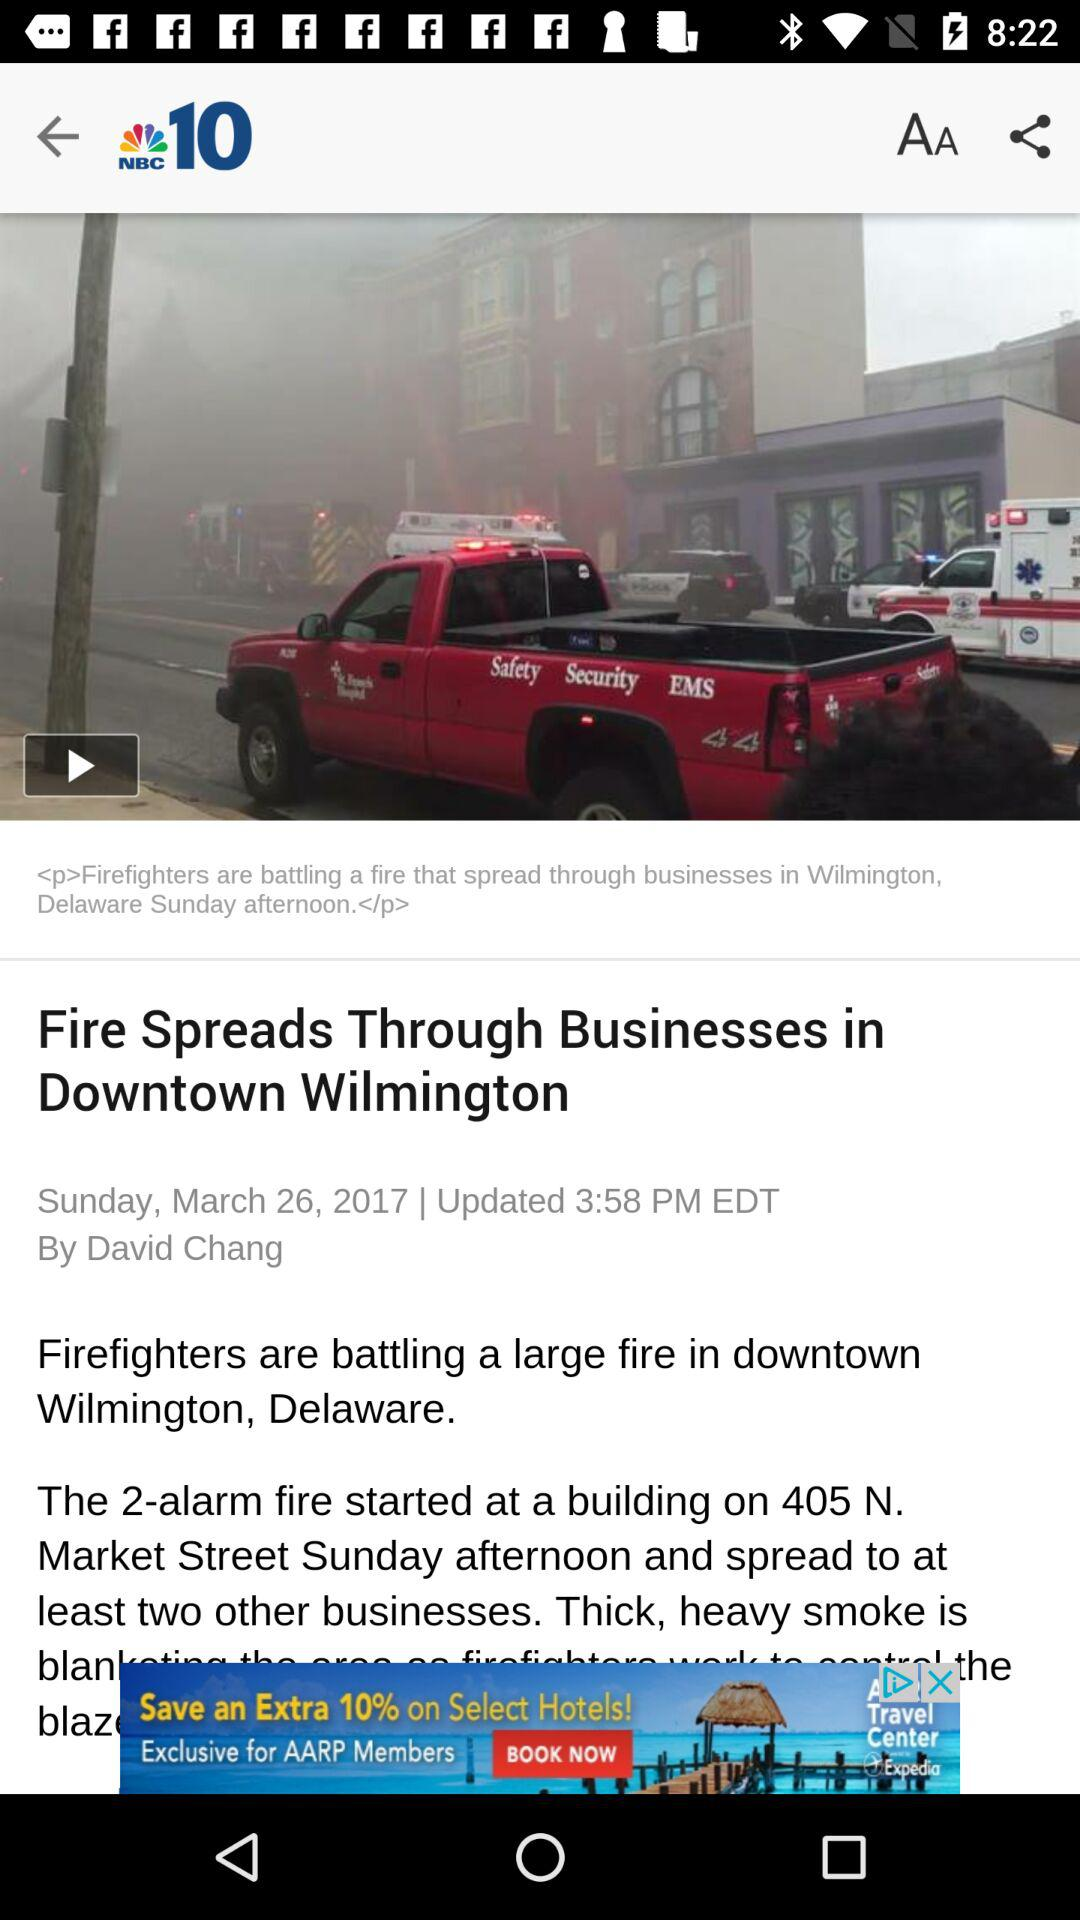What is the publication date of the article? The publication date is Sunday, March 26, 2017. 